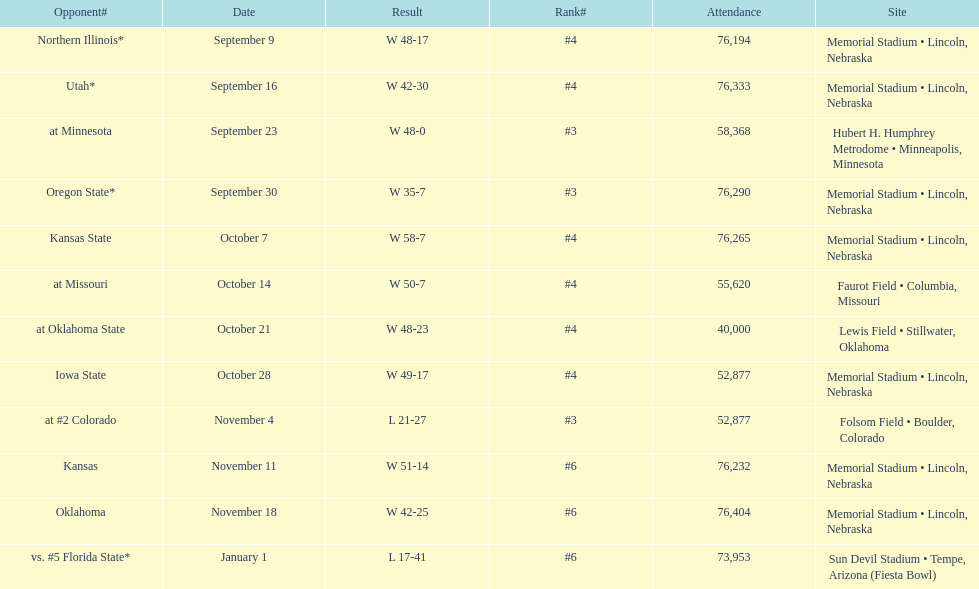How many victories did they have with a margin of over 7 points? 10. 